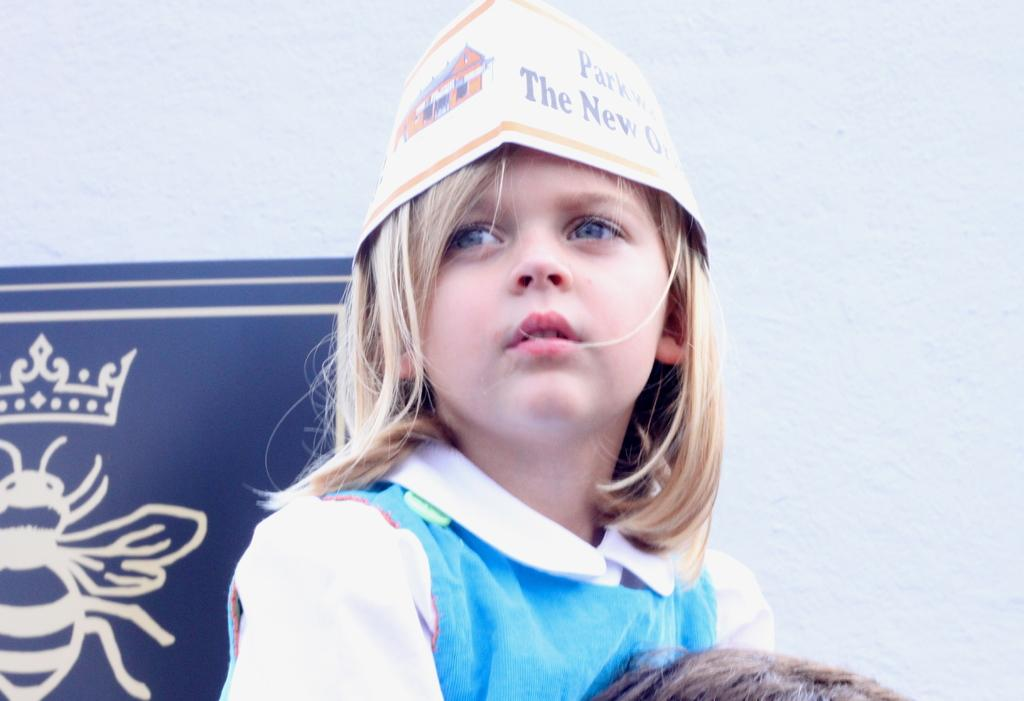Provide a one-sentence caption for the provided image. A young girl wears a paper hat with a partially visible phrase on it which reads "The New". 